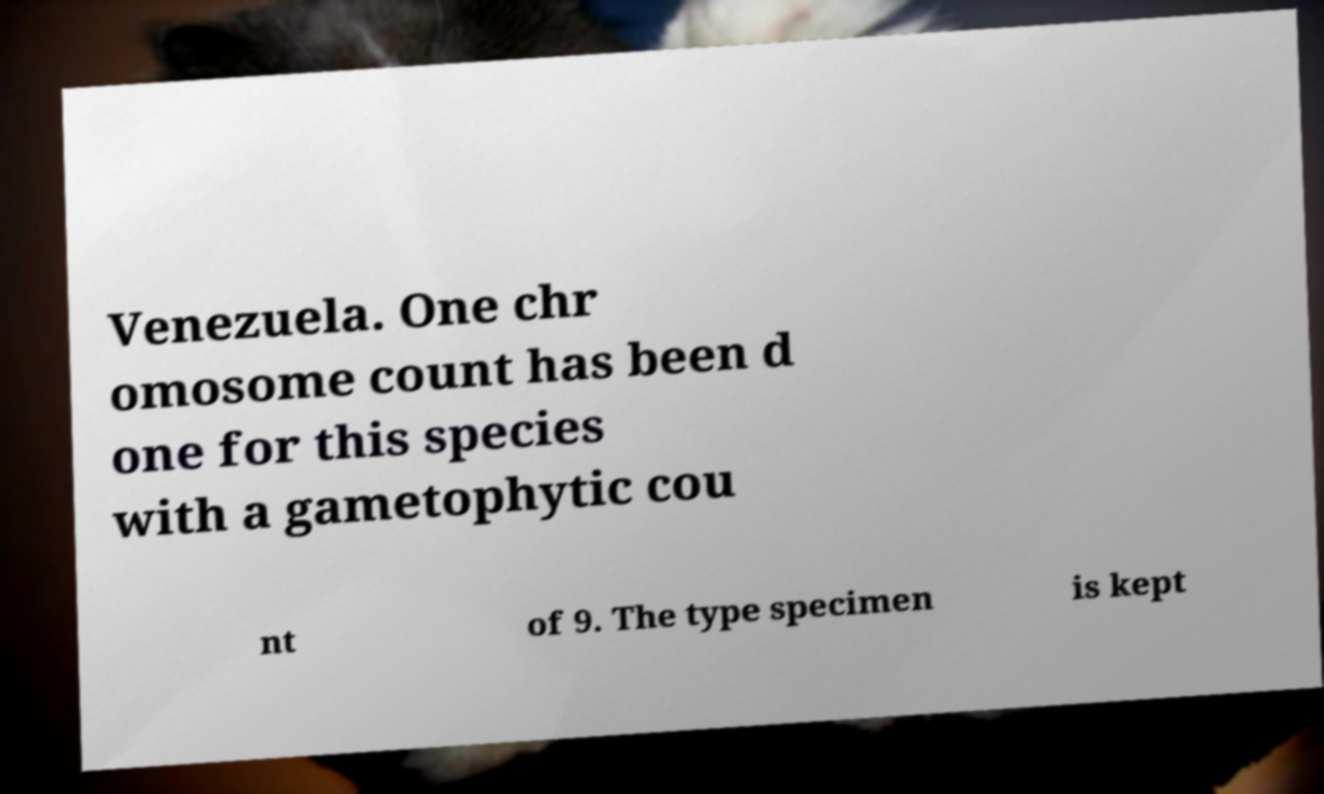What messages or text are displayed in this image? I need them in a readable, typed format. Venezuela. One chr omosome count has been d one for this species with a gametophytic cou nt of 9. The type specimen is kept 